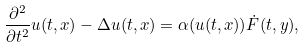<formula> <loc_0><loc_0><loc_500><loc_500>\frac { \partial ^ { 2 } } { \partial t ^ { 2 } } u ( t , x ) - \Delta u ( t , x ) = \alpha ( u ( t , x ) ) { \dot { F } } ( t , y ) ,</formula> 